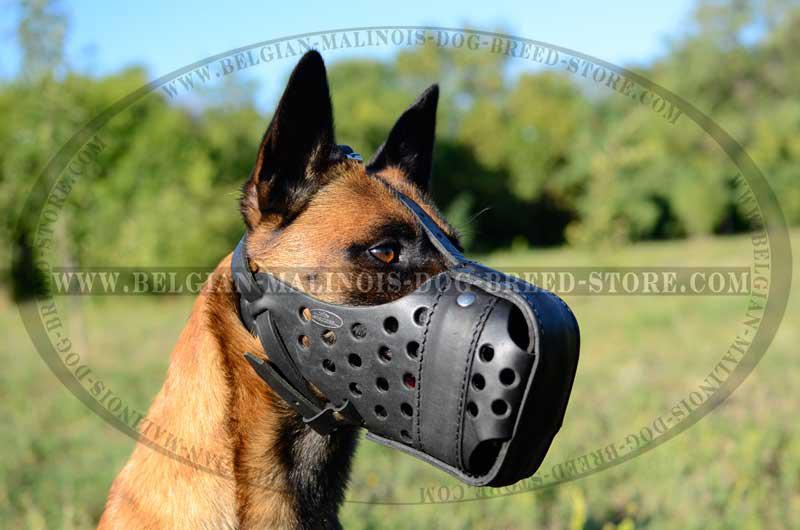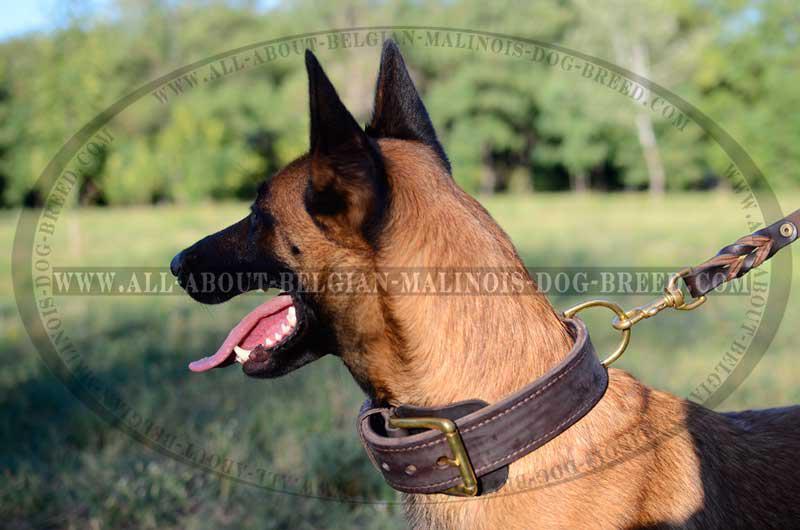The first image is the image on the left, the second image is the image on the right. For the images displayed, is the sentence "One of the dogs is on a leash." factually correct? Answer yes or no. Yes. 